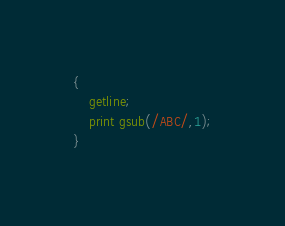<code> <loc_0><loc_0><loc_500><loc_500><_Awk_>{
    getline;
    print gsub(/ABC/,1);
}</code> 